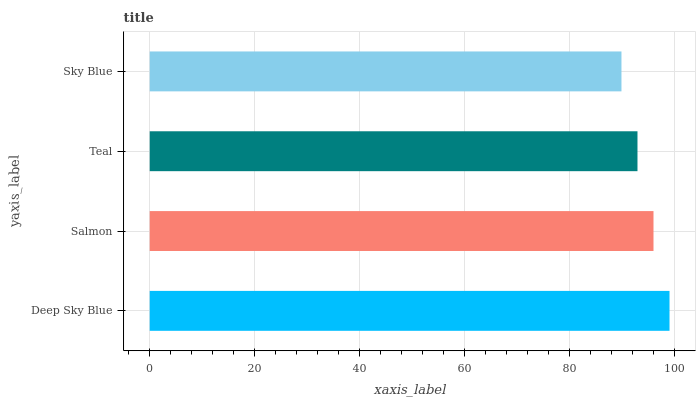Is Sky Blue the minimum?
Answer yes or no. Yes. Is Deep Sky Blue the maximum?
Answer yes or no. Yes. Is Salmon the minimum?
Answer yes or no. No. Is Salmon the maximum?
Answer yes or no. No. Is Deep Sky Blue greater than Salmon?
Answer yes or no. Yes. Is Salmon less than Deep Sky Blue?
Answer yes or no. Yes. Is Salmon greater than Deep Sky Blue?
Answer yes or no. No. Is Deep Sky Blue less than Salmon?
Answer yes or no. No. Is Salmon the high median?
Answer yes or no. Yes. Is Teal the low median?
Answer yes or no. Yes. Is Teal the high median?
Answer yes or no. No. Is Deep Sky Blue the low median?
Answer yes or no. No. 